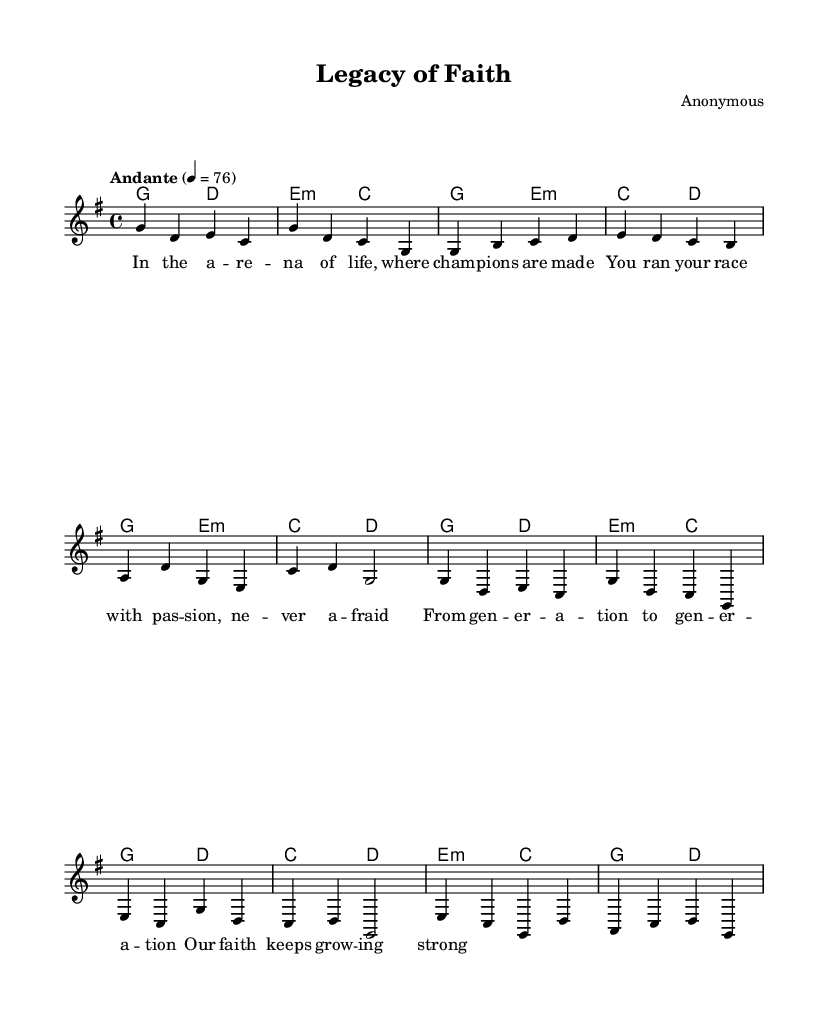What is the key signature of this music? The key signature is G major, which has one sharp (F#). This can be determined by looking at the key signature indicated in the score section.
Answer: G major What is the time signature of this music? The time signature is 4/4, indicating four beats per measure with a quarter note receiving one beat. This information is found at the beginning of the score following the key signature notation.
Answer: 4/4 What is the tempo marking for this piece? The tempo marking is "Andante," which typically implies a moderate pace. This can be seen in the tempo line located in the global section of the score.
Answer: Andante How many measures are in the chorus section? The chorus consists of four measures, as indicated in the sheet music where each line corresponds to one measure until the end of the chorus lyrics is reached.
Answer: Four What is the primary theme expressed in the lyrics? The primary theme is about the intergenerational passing of faith, as conveyed through the lyrics which refer to the continuity and strength of faith across generations. This inference is made by analyzing the lyrics provided in the score.
Answer: Passing of faith Which instruments are indicated to play in this piece? The score indicates the use of a staff for a lead voice and specifies chord names, suggesting piano or guitar accompaniment. This is derived from the structured layout of the score where different parts are clearly labeled.
Answer: Lead voice and chords What does the bridge represent in this composition? The bridge serves as a contrasting section that deepens the emotional narrative, reflecting the transition between the verses and the return to the chorus. This conclusion is based on its placement and function within the overall structure of the song.
Answer: Emotional transition 